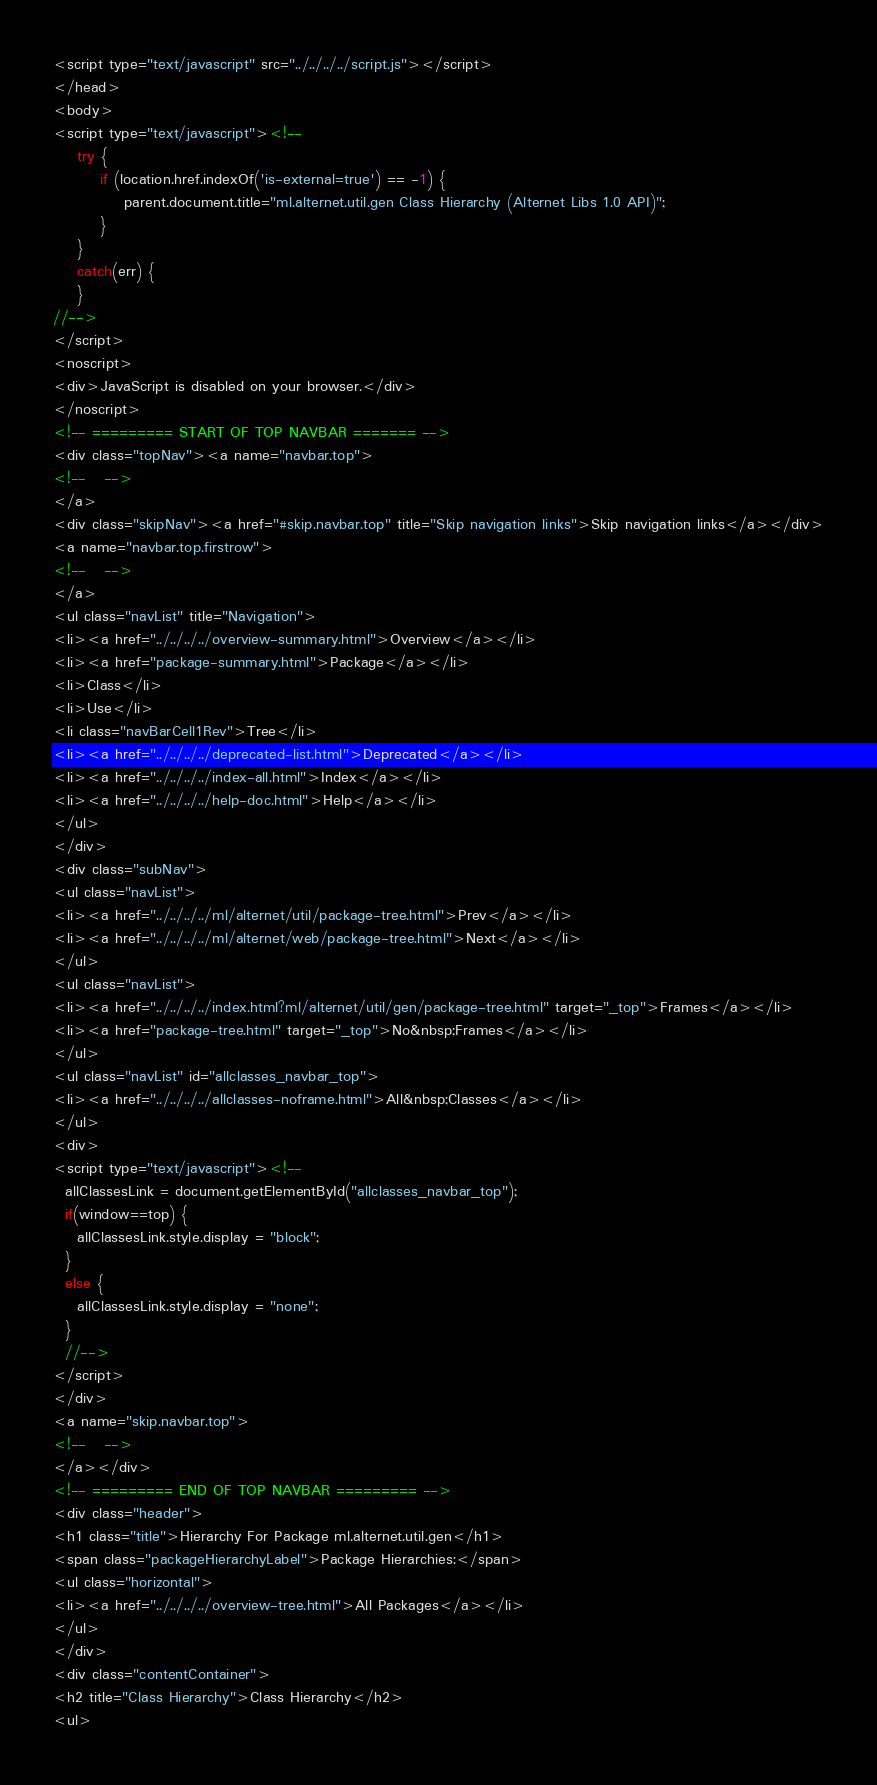<code> <loc_0><loc_0><loc_500><loc_500><_HTML_><script type="text/javascript" src="../../../../script.js"></script>
</head>
<body>
<script type="text/javascript"><!--
    try {
        if (location.href.indexOf('is-external=true') == -1) {
            parent.document.title="ml.alternet.util.gen Class Hierarchy (Alternet Libs 1.0 API)";
        }
    }
    catch(err) {
    }
//-->
</script>
<noscript>
<div>JavaScript is disabled on your browser.</div>
</noscript>
<!-- ========= START OF TOP NAVBAR ======= -->
<div class="topNav"><a name="navbar.top">
<!--   -->
</a>
<div class="skipNav"><a href="#skip.navbar.top" title="Skip navigation links">Skip navigation links</a></div>
<a name="navbar.top.firstrow">
<!--   -->
</a>
<ul class="navList" title="Navigation">
<li><a href="../../../../overview-summary.html">Overview</a></li>
<li><a href="package-summary.html">Package</a></li>
<li>Class</li>
<li>Use</li>
<li class="navBarCell1Rev">Tree</li>
<li><a href="../../../../deprecated-list.html">Deprecated</a></li>
<li><a href="../../../../index-all.html">Index</a></li>
<li><a href="../../../../help-doc.html">Help</a></li>
</ul>
</div>
<div class="subNav">
<ul class="navList">
<li><a href="../../../../ml/alternet/util/package-tree.html">Prev</a></li>
<li><a href="../../../../ml/alternet/web/package-tree.html">Next</a></li>
</ul>
<ul class="navList">
<li><a href="../../../../index.html?ml/alternet/util/gen/package-tree.html" target="_top">Frames</a></li>
<li><a href="package-tree.html" target="_top">No&nbsp;Frames</a></li>
</ul>
<ul class="navList" id="allclasses_navbar_top">
<li><a href="../../../../allclasses-noframe.html">All&nbsp;Classes</a></li>
</ul>
<div>
<script type="text/javascript"><!--
  allClassesLink = document.getElementById("allclasses_navbar_top");
  if(window==top) {
    allClassesLink.style.display = "block";
  }
  else {
    allClassesLink.style.display = "none";
  }
  //-->
</script>
</div>
<a name="skip.navbar.top">
<!--   -->
</a></div>
<!-- ========= END OF TOP NAVBAR ========= -->
<div class="header">
<h1 class="title">Hierarchy For Package ml.alternet.util.gen</h1>
<span class="packageHierarchyLabel">Package Hierarchies:</span>
<ul class="horizontal">
<li><a href="../../../../overview-tree.html">All Packages</a></li>
</ul>
</div>
<div class="contentContainer">
<h2 title="Class Hierarchy">Class Hierarchy</h2>
<ul></code> 